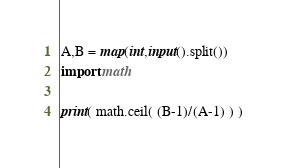<code> <loc_0><loc_0><loc_500><loc_500><_Python_>A,B = map(int,input().split())
import math

print( math.ceil( (B-1)/(A-1) ) )</code> 